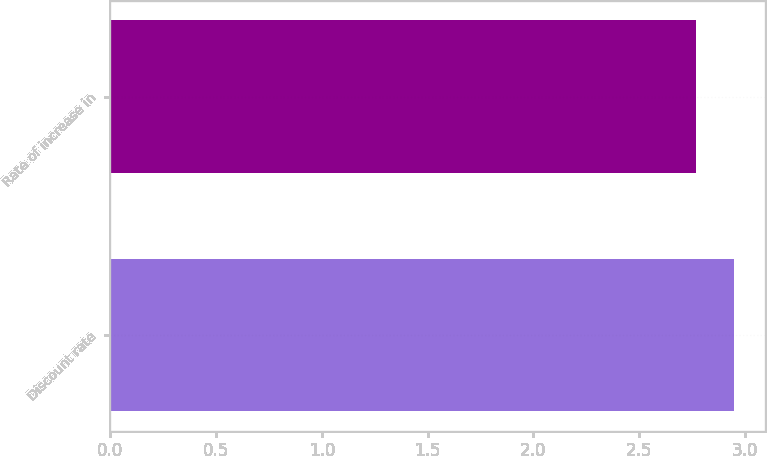Convert chart to OTSL. <chart><loc_0><loc_0><loc_500><loc_500><bar_chart><fcel>Discount rate<fcel>Rate of increase in<nl><fcel>2.95<fcel>2.77<nl></chart> 